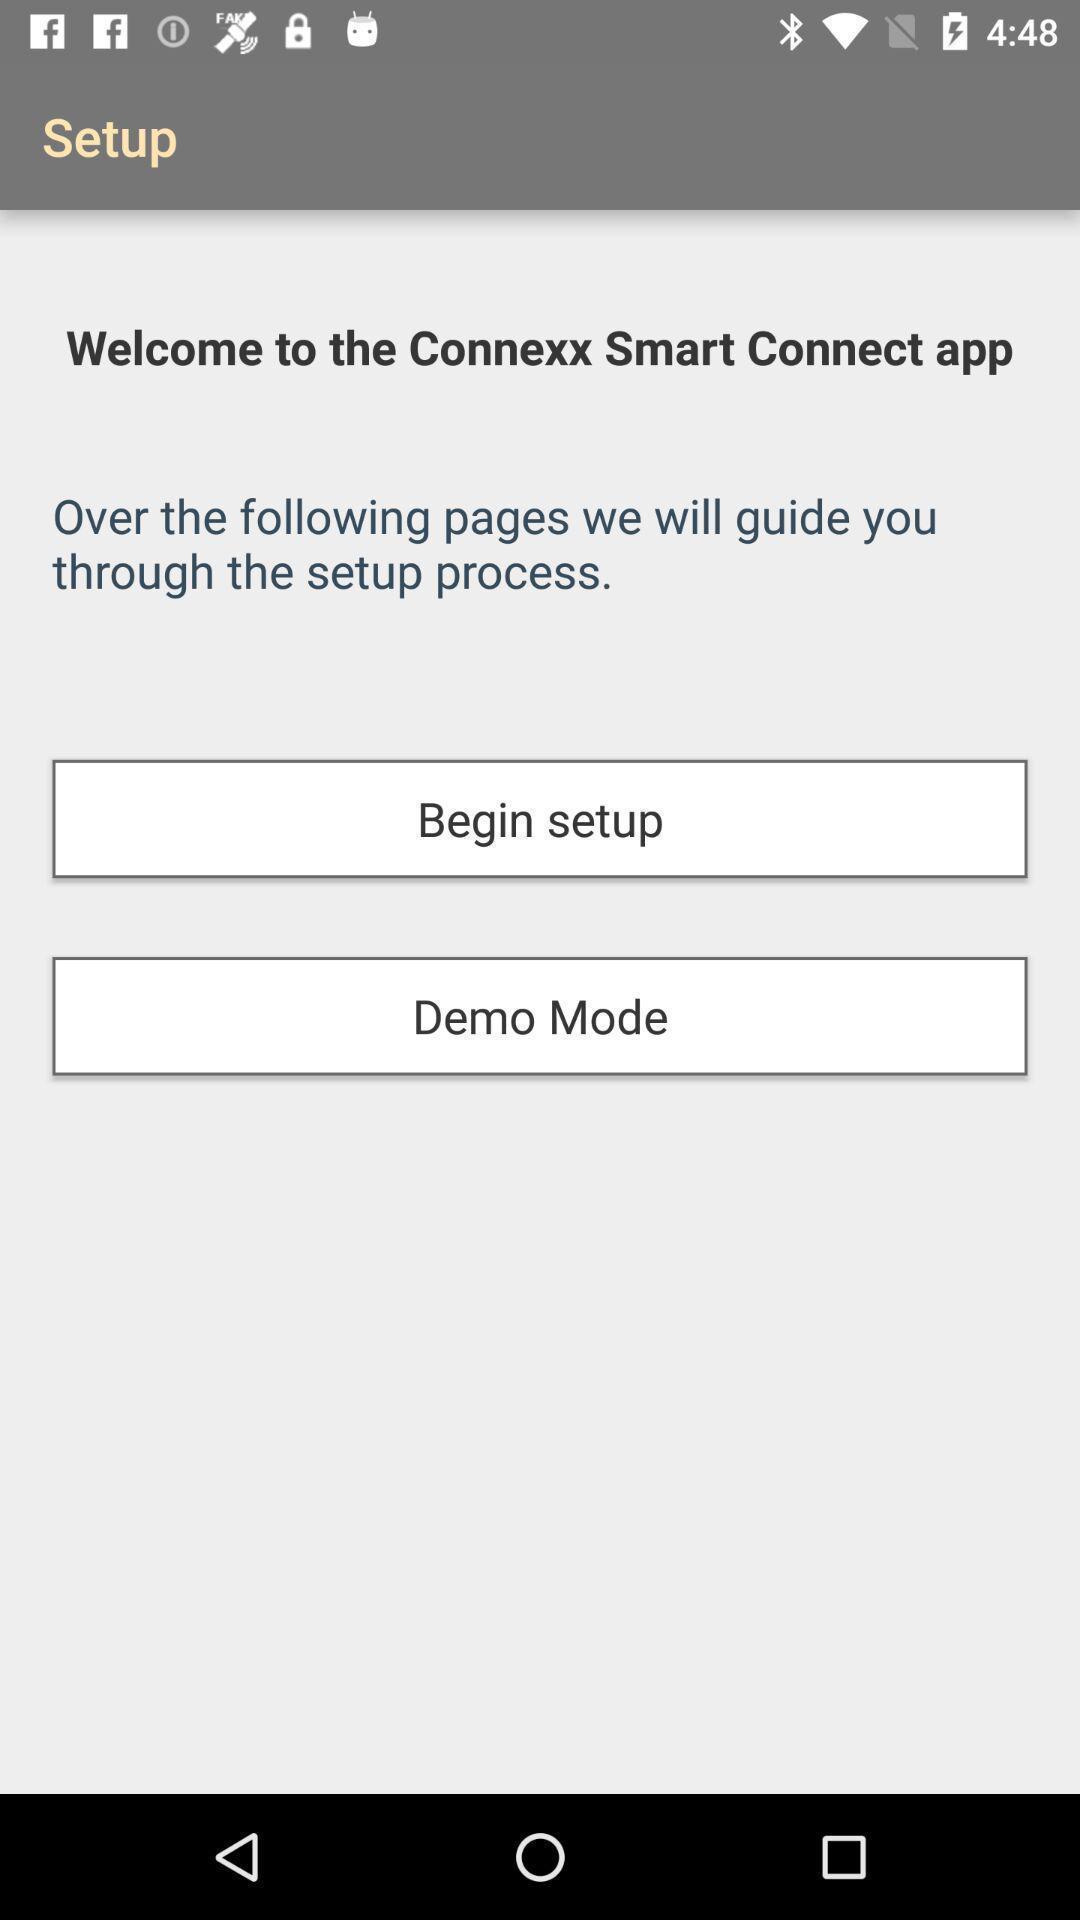What can you discern from this picture? Welcome page. 